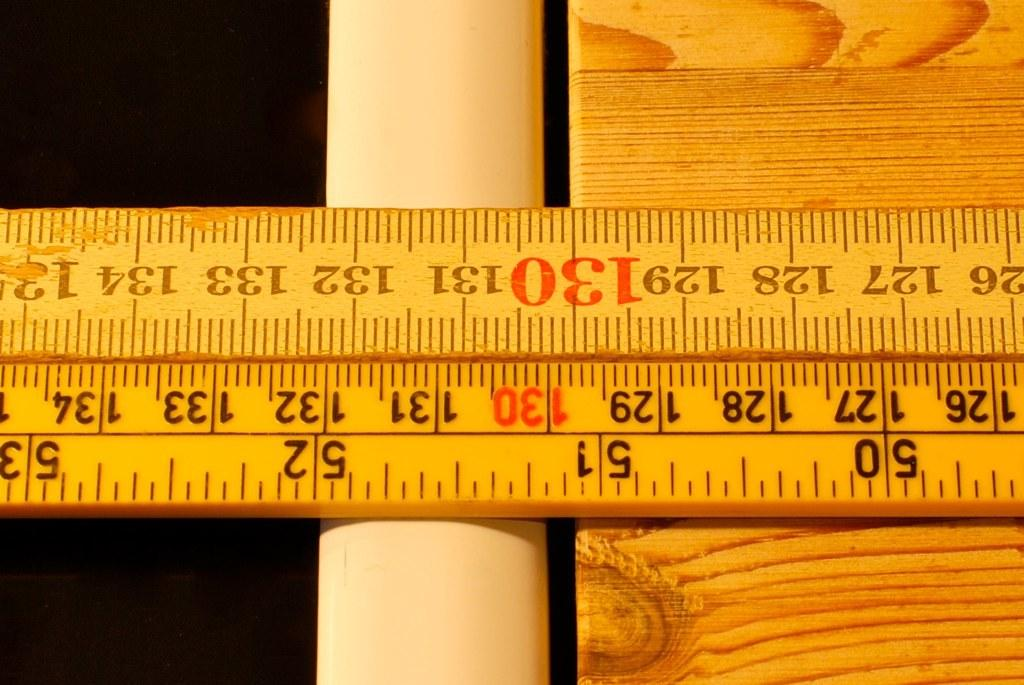What can be seen on the wooden platform in the image? There is a scale on a wooden platform. What else is present in the image besides the scale and wooden platform? There is a paper in the image. How would you describe the overall lighting in the image? The background of the image is dark. What type of cakes are being exchanged in the image? There are no cakes or exchange of items depicted in the image. How does the scale attack the wooden platform in the image? The scale does not attack the wooden platform; it is simply placed on it. 